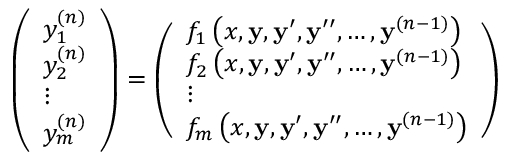Convert formula to latex. <formula><loc_0><loc_0><loc_500><loc_500>{ \left ( \begin{array} { l } { y _ { 1 } ^ { ( n ) } } \\ { y _ { 2 } ^ { ( n ) } } \\ { \vdots } \\ { y _ { m } ^ { ( n ) } } \end{array} \right ) } = { \left ( \begin{array} { l } { f _ { 1 } \left ( x , y , y ^ { \prime } , y ^ { \prime \prime } , \dots , y ^ { ( n - 1 ) } \right ) } \\ { f _ { 2 } \left ( x , y , y ^ { \prime } , y ^ { \prime \prime } , \dots , y ^ { ( n - 1 ) } \right ) } \\ { \vdots } \\ { f _ { m } \left ( x , y , y ^ { \prime } , y ^ { \prime \prime } , \dots , y ^ { ( n - 1 ) } \right ) } \end{array} \right ) }</formula> 